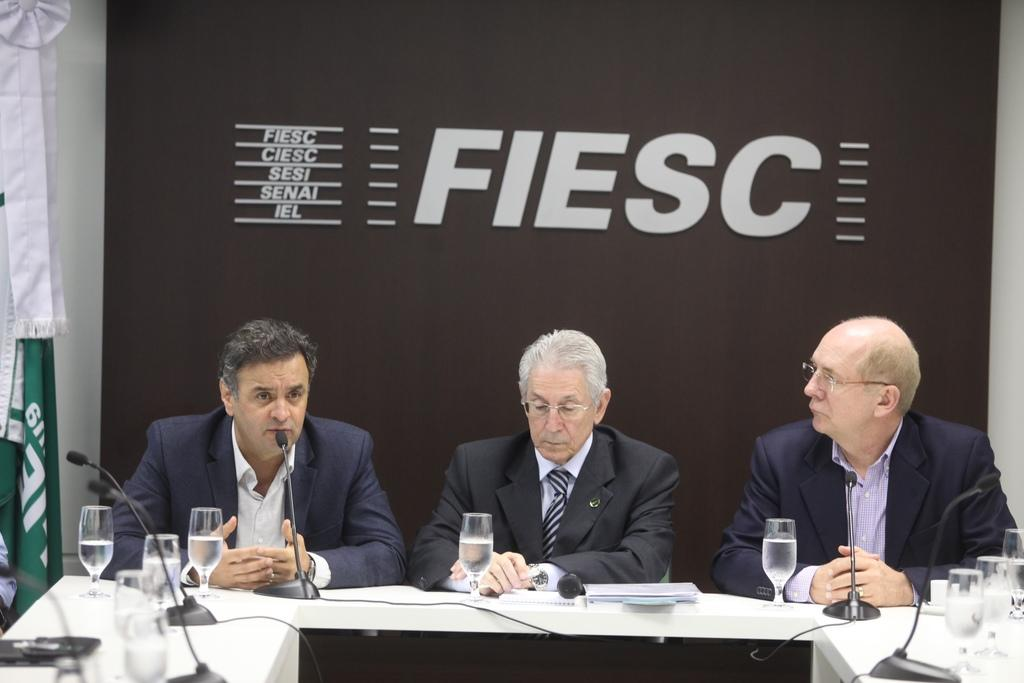How many people are in the image? There is a group of people in the image. What are the people doing in the image? The people are sitting on chairs. What is on the table in the image? There is a glass on the table, and there are objects on the table. Can you describe the table in the image? There is a table in the image. What is the tendency of the summer season in the image? There is no mention of a season or any tendency related to it in the image. 